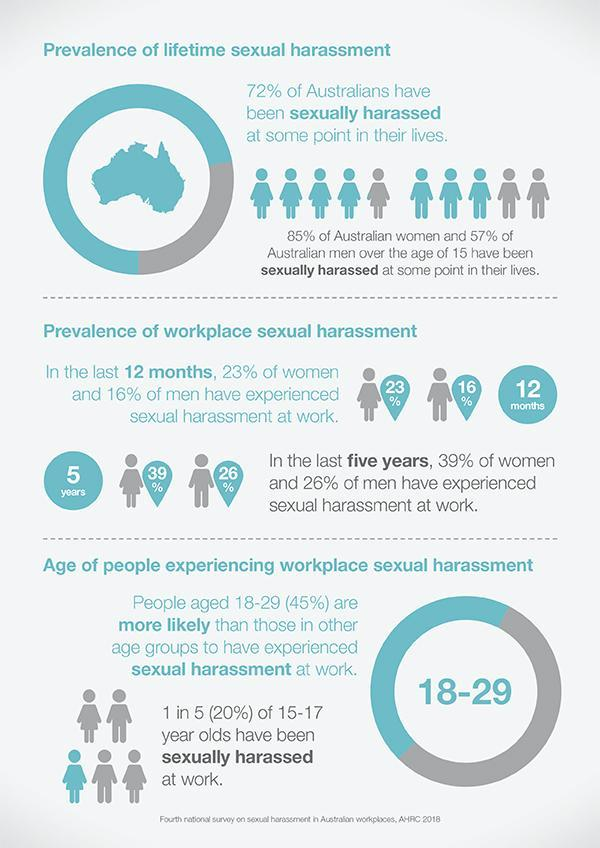Who has faced sexual harassment the most in Australia?
Answer the question with a short phrase. women 